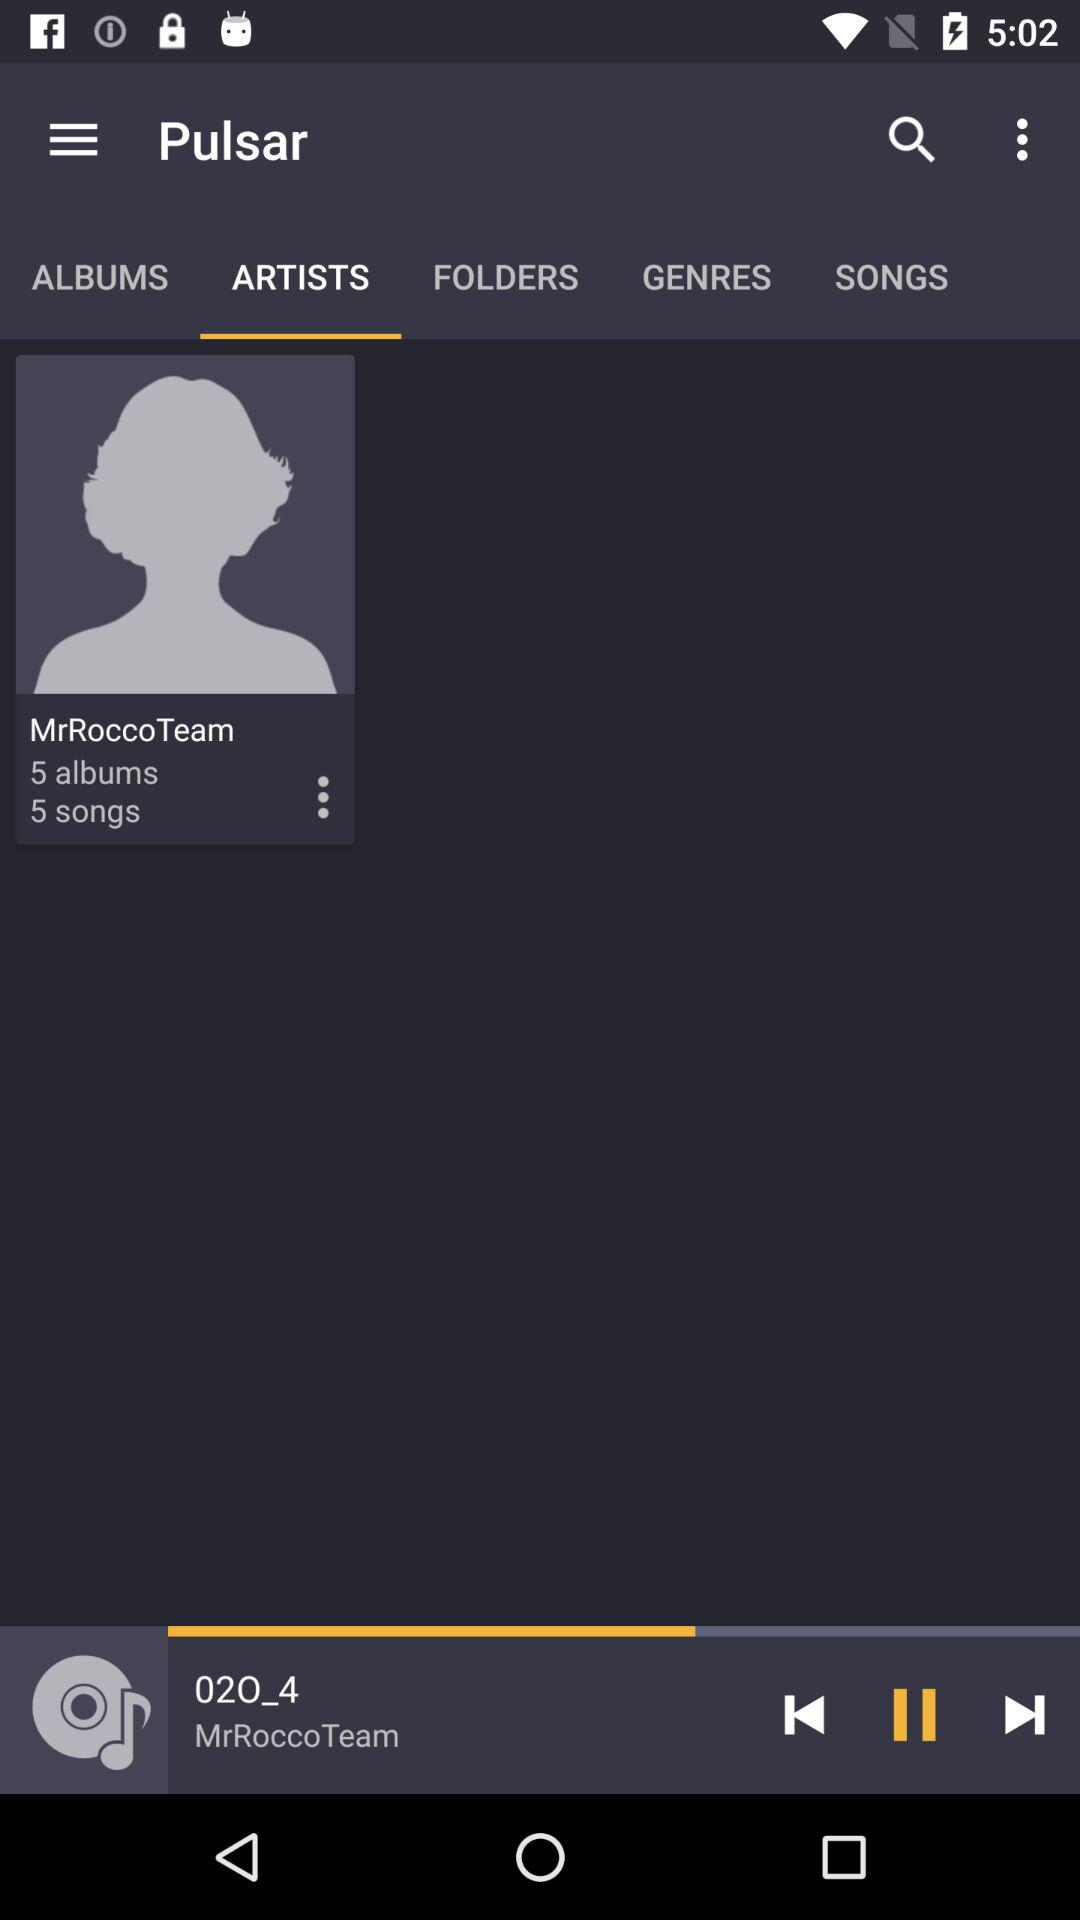Which song is playing? The song playing is "02O_4". 